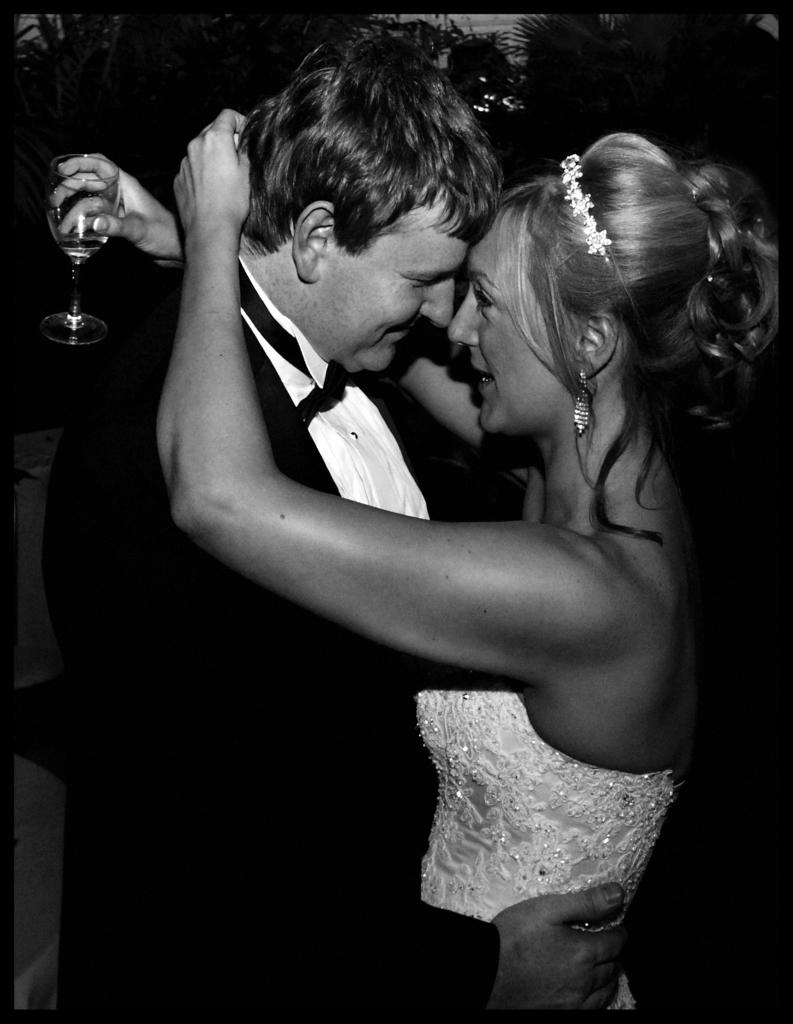Who are the people in the image? There is a man and a woman in the image. What are the man and woman doing in the image? The man and woman are hugging each other. What expressions do the man and woman have in the image? Both the man and woman are smiling. Who else is holding a glass in the image? There is a woman holding a glass in the image. What is the color of the background in the image? The background of the image is dark. What type of scarecrow can be seen in the image? There is no scarecrow present in the image. What holiday is being celebrated in the image? There is no indication of a holiday being celebrated in the image. 